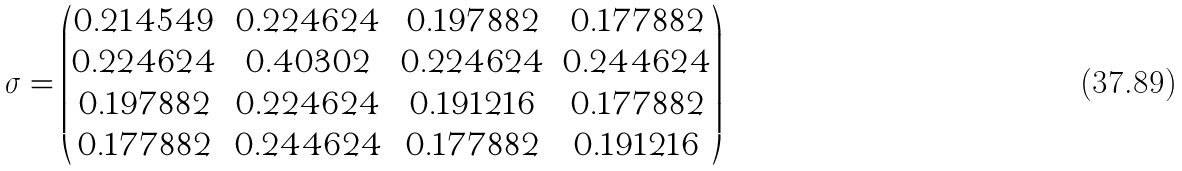<formula> <loc_0><loc_0><loc_500><loc_500>\sigma = \begin{pmatrix} 0 . 2 1 4 5 4 9 & 0 . 2 2 4 6 2 4 & 0 . 1 9 7 8 8 2 & 0 . 1 7 7 8 8 2 \\ 0 . 2 2 4 6 2 4 & 0 . 4 0 3 0 2 & 0 . 2 2 4 6 2 4 & 0 . 2 4 4 6 2 4 \\ 0 . 1 9 7 8 8 2 & 0 . 2 2 4 6 2 4 & 0 . 1 9 1 2 1 6 & 0 . 1 7 7 8 8 2 \\ 0 . 1 7 7 8 8 2 & 0 . 2 4 4 6 2 4 & 0 . 1 7 7 8 8 2 & 0 . 1 9 1 2 1 6 \\ \end{pmatrix}</formula> 